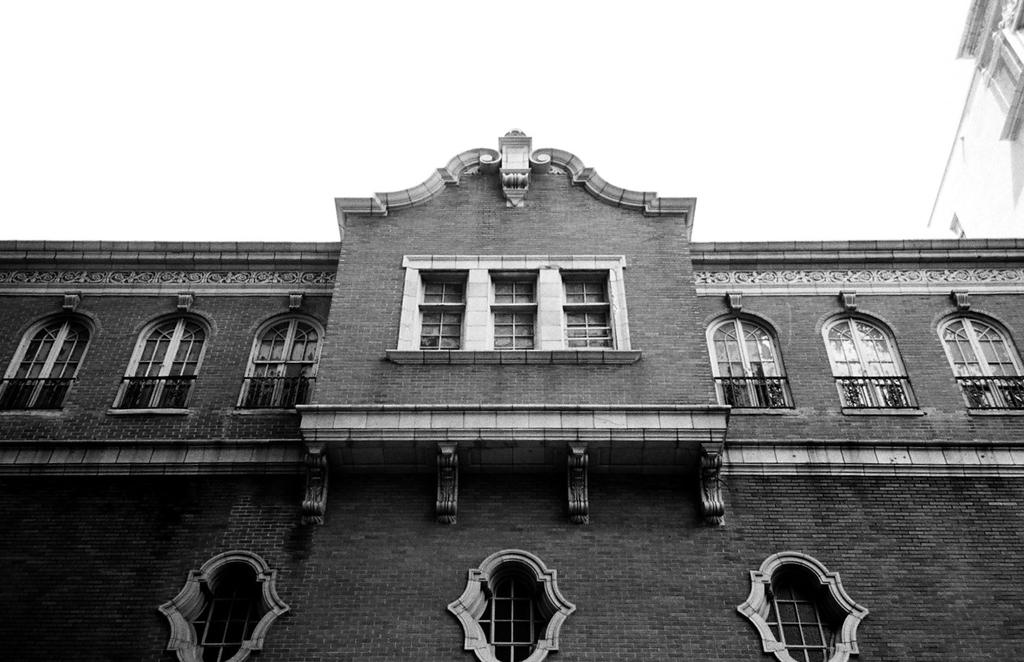What type of structure is visible in the image? There is a building with windows in the image. Can you describe the appearance of the building? The building has windows and is white in color. Are there any other buildings visible in the image? Yes, there is a white-colored building beside the first building. What type of stew is being prepared in the building? There is no indication of any stew being prepared in the building; the image only shows the exterior of the building. 